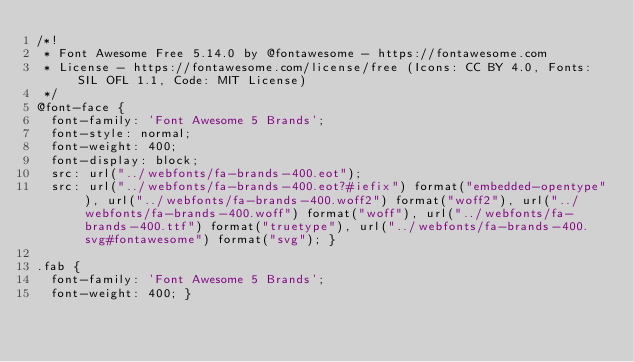<code> <loc_0><loc_0><loc_500><loc_500><_CSS_>/*!
 * Font Awesome Free 5.14.0 by @fontawesome - https://fontawesome.com
 * License - https://fontawesome.com/license/free (Icons: CC BY 4.0, Fonts: SIL OFL 1.1, Code: MIT License)
 */
@font-face {
  font-family: 'Font Awesome 5 Brands';
  font-style: normal;
  font-weight: 400;
  font-display: block;
  src: url("../webfonts/fa-brands-400.eot");
  src: url("../webfonts/fa-brands-400.eot?#iefix") format("embedded-opentype"), url("../webfonts/fa-brands-400.woff2") format("woff2"), url("../webfonts/fa-brands-400.woff") format("woff"), url("../webfonts/fa-brands-400.ttf") format("truetype"), url("../webfonts/fa-brands-400.svg#fontawesome") format("svg"); }

.fab {
  font-family: 'Font Awesome 5 Brands';
  font-weight: 400; }
</code> 